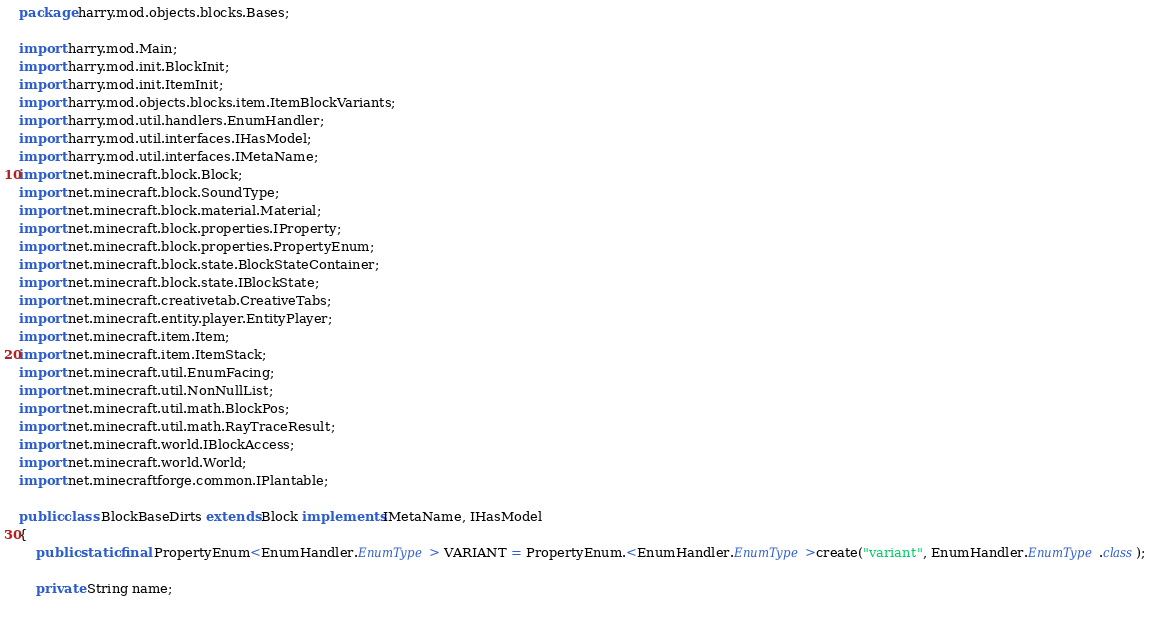Convert code to text. <code><loc_0><loc_0><loc_500><loc_500><_Java_>package harry.mod.objects.blocks.Bases;

import harry.mod.Main;
import harry.mod.init.BlockInit;
import harry.mod.init.ItemInit;
import harry.mod.objects.blocks.item.ItemBlockVariants;
import harry.mod.util.handlers.EnumHandler;
import harry.mod.util.interfaces.IHasModel;
import harry.mod.util.interfaces.IMetaName;
import net.minecraft.block.Block;
import net.minecraft.block.SoundType;
import net.minecraft.block.material.Material;
import net.minecraft.block.properties.IProperty;
import net.minecraft.block.properties.PropertyEnum;
import net.minecraft.block.state.BlockStateContainer;
import net.minecraft.block.state.IBlockState;
import net.minecraft.creativetab.CreativeTabs;
import net.minecraft.entity.player.EntityPlayer;
import net.minecraft.item.Item;
import net.minecraft.item.ItemStack;
import net.minecraft.util.EnumFacing;
import net.minecraft.util.NonNullList;
import net.minecraft.util.math.BlockPos;
import net.minecraft.util.math.RayTraceResult;
import net.minecraft.world.IBlockAccess;
import net.minecraft.world.World;
import net.minecraftforge.common.IPlantable;

public class BlockBaseDirts extends Block implements IMetaName, IHasModel
{
	public static final PropertyEnum<EnumHandler.EnumType> VARIANT = PropertyEnum.<EnumHandler.EnumType>create("variant", EnumHandler.EnumType.class);
	
	private String name;
	</code> 